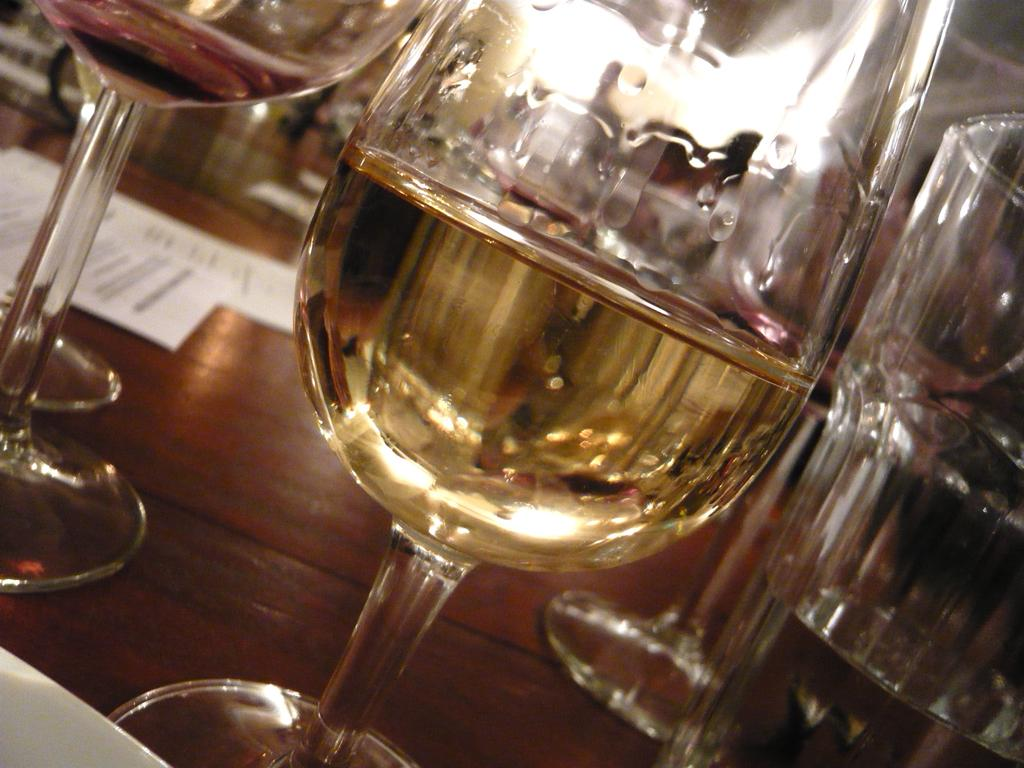What objects are on the wooden surface in the image? There are glasses with liquid and papers on the wooden surface. What might be the purpose of the glasses with liquid? The glasses with liquid might be for drinking or holding a beverage. What can be inferred about the papers on the wooden surface? The papers might be for writing, reading, or displaying information. What type of furniture is visible in the image? There is no furniture visible in the image; only a wooden surface with glasses and papers is present. 